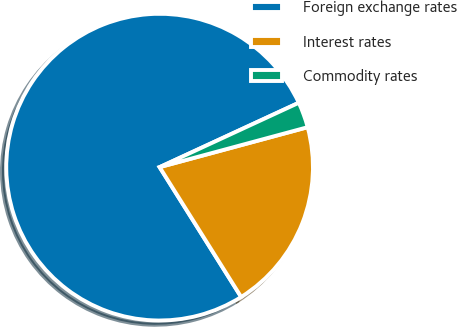Convert chart. <chart><loc_0><loc_0><loc_500><loc_500><pie_chart><fcel>Foreign exchange rates<fcel>Interest rates<fcel>Commodity rates<nl><fcel>77.03%<fcel>20.27%<fcel>2.7%<nl></chart> 